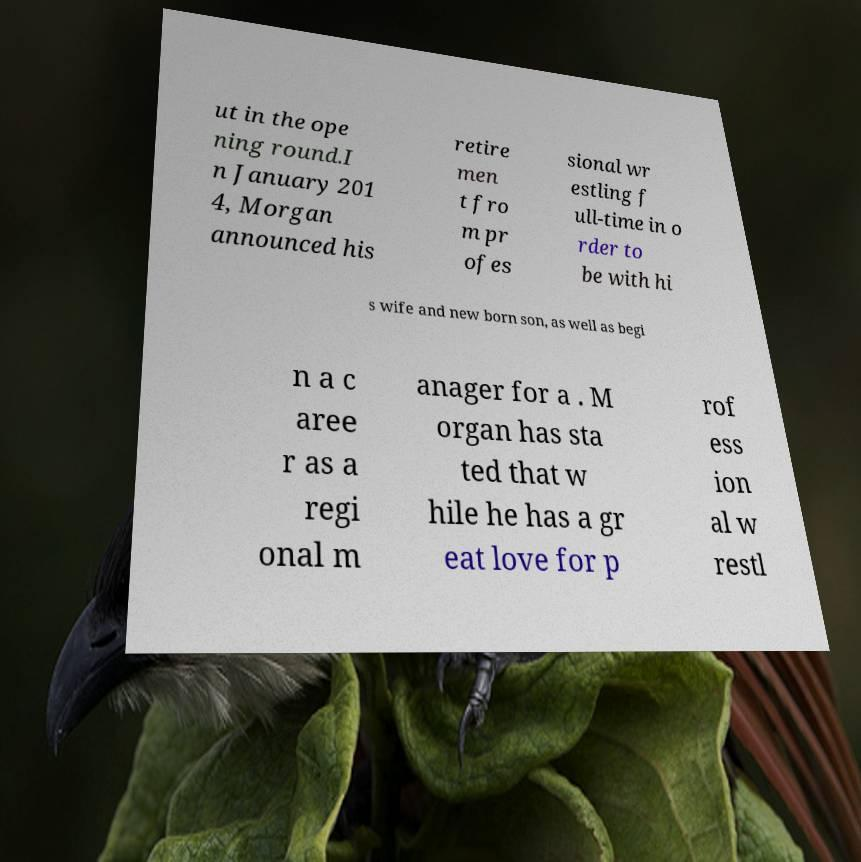For documentation purposes, I need the text within this image transcribed. Could you provide that? ut in the ope ning round.I n January 201 4, Morgan announced his retire men t fro m pr ofes sional wr estling f ull-time in o rder to be with hi s wife and new born son, as well as begi n a c aree r as a regi onal m anager for a . M organ has sta ted that w hile he has a gr eat love for p rof ess ion al w restl 